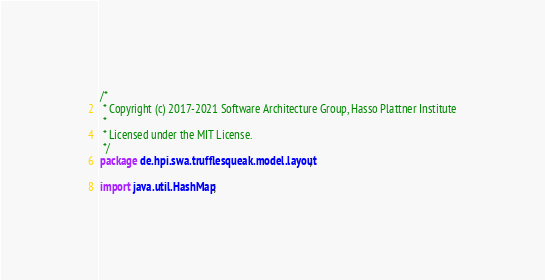Convert code to text. <code><loc_0><loc_0><loc_500><loc_500><_Java_>/*
 * Copyright (c) 2017-2021 Software Architecture Group, Hasso Plattner Institute
 *
 * Licensed under the MIT License.
 */
package de.hpi.swa.trufflesqueak.model.layout;

import java.util.HashMap;
</code> 